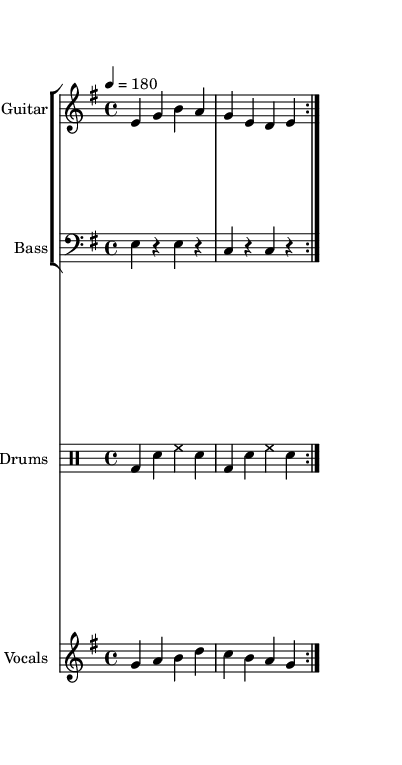What is the key signature of this music? The key signature is E minor, which has one sharp (F#) indicated by the key signature at the beginning of the staff.
Answer: E minor What is the time signature of this music? The time signature is 4/4, represented by the notation at the beginning of the score, allowing four beats per measure.
Answer: 4/4 What is the tempo marking for this piece? The tempo marking is indicated as "4 = 180," meaning there are 180 beats per minute corresponding to the quarter note.
Answer: 180 How many measures are repeated in the guitar part? The guitar part has two measures that are repeated, as indicated by the "volta" marking at the beginning of the guitar music section.
Answer: 2 What is the predominant lyrical theme of this song? The lyrics explore corporate rebellion, as seen in phrases like "Suit and tie, they're just disguise," indicating a critique of corporate culture.
Answer: Corporate rebellion What percussion instruments are used in this music? The percussion instruments used include bass drum, snare, and hi-hat, as identified from the drummode notation showing their respective symbols.
Answer: Bass drum, snare, hi-hat What is the main vocal melody note that corresponds with the lyrics "Crunching numbers"? The vocal melody note that corresponds with "Crunching numbers" is A, as seen in the notation for the vocal staff during these lyrics.
Answer: A 